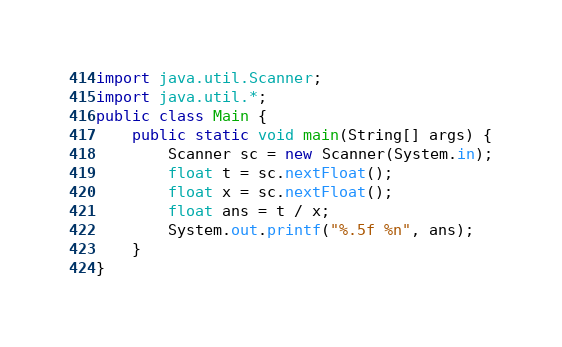<code> <loc_0><loc_0><loc_500><loc_500><_Java_>import java.util.Scanner;
import java.util.*;
public class Main {
    public static void main(String[] args) {
        Scanner sc = new Scanner(System.in);
        float t = sc.nextFloat();
        float x = sc.nextFloat();
        float ans = t / x;
        System.out.printf("%.5f %n", ans);
    }
}
</code> 